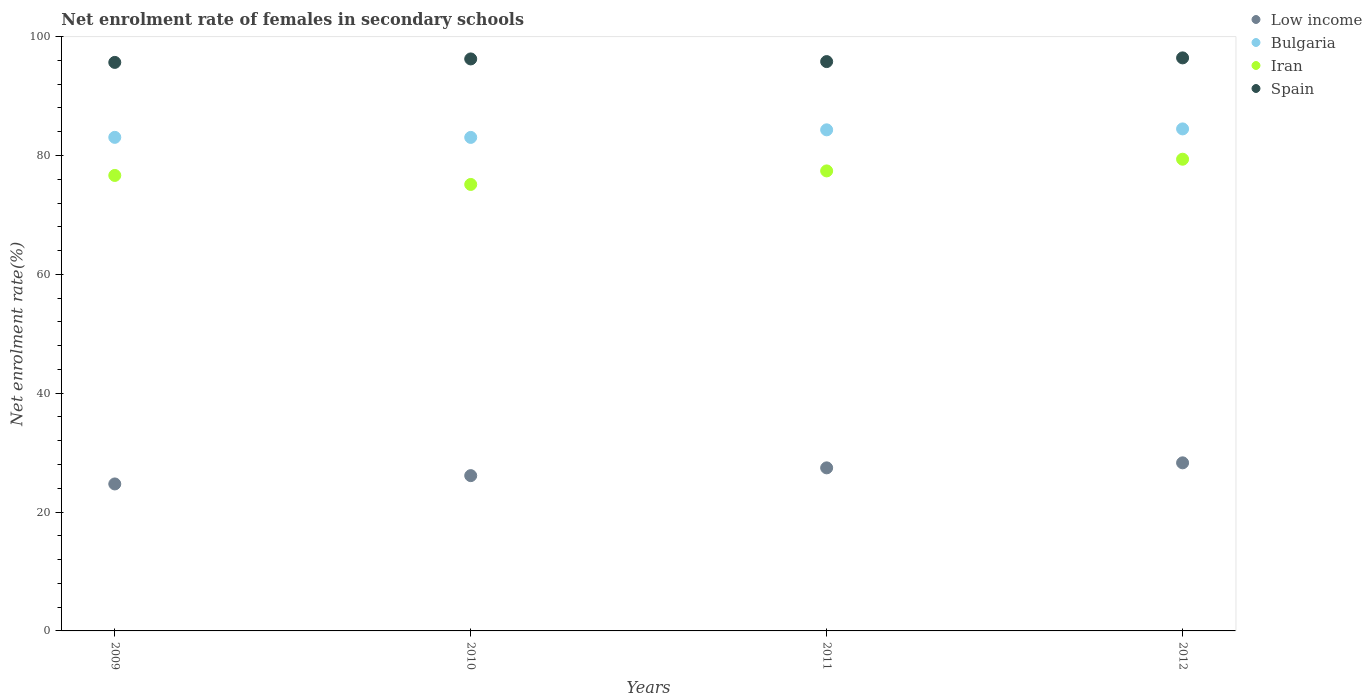Is the number of dotlines equal to the number of legend labels?
Offer a very short reply. Yes. What is the net enrolment rate of females in secondary schools in Spain in 2009?
Offer a terse response. 95.66. Across all years, what is the maximum net enrolment rate of females in secondary schools in Spain?
Offer a very short reply. 96.42. Across all years, what is the minimum net enrolment rate of females in secondary schools in Iran?
Offer a very short reply. 75.12. In which year was the net enrolment rate of females in secondary schools in Low income maximum?
Ensure brevity in your answer.  2012. What is the total net enrolment rate of females in secondary schools in Spain in the graph?
Provide a short and direct response. 384.12. What is the difference between the net enrolment rate of females in secondary schools in Spain in 2009 and that in 2012?
Your answer should be very brief. -0.76. What is the difference between the net enrolment rate of females in secondary schools in Bulgaria in 2011 and the net enrolment rate of females in secondary schools in Spain in 2009?
Offer a very short reply. -11.35. What is the average net enrolment rate of females in secondary schools in Iran per year?
Ensure brevity in your answer.  77.13. In the year 2011, what is the difference between the net enrolment rate of females in secondary schools in Iran and net enrolment rate of females in secondary schools in Spain?
Provide a succinct answer. -18.39. In how many years, is the net enrolment rate of females in secondary schools in Spain greater than 84 %?
Provide a short and direct response. 4. What is the ratio of the net enrolment rate of females in secondary schools in Iran in 2011 to that in 2012?
Offer a terse response. 0.98. Is the difference between the net enrolment rate of females in secondary schools in Iran in 2009 and 2011 greater than the difference between the net enrolment rate of females in secondary schools in Spain in 2009 and 2011?
Offer a very short reply. No. What is the difference between the highest and the second highest net enrolment rate of females in secondary schools in Iran?
Offer a terse response. 1.97. What is the difference between the highest and the lowest net enrolment rate of females in secondary schools in Bulgaria?
Your response must be concise. 1.43. In how many years, is the net enrolment rate of females in secondary schools in Bulgaria greater than the average net enrolment rate of females in secondary schools in Bulgaria taken over all years?
Offer a very short reply. 2. Does the net enrolment rate of females in secondary schools in Low income monotonically increase over the years?
Provide a succinct answer. Yes. How many dotlines are there?
Keep it short and to the point. 4. What is the difference between two consecutive major ticks on the Y-axis?
Make the answer very short. 20. Does the graph contain any zero values?
Offer a very short reply. No. Does the graph contain grids?
Make the answer very short. No. What is the title of the graph?
Provide a short and direct response. Net enrolment rate of females in secondary schools. What is the label or title of the X-axis?
Give a very brief answer. Years. What is the label or title of the Y-axis?
Give a very brief answer. Net enrolment rate(%). What is the Net enrolment rate(%) in Low income in 2009?
Your answer should be compact. 24.73. What is the Net enrolment rate(%) of Bulgaria in 2009?
Your answer should be compact. 83.05. What is the Net enrolment rate(%) in Iran in 2009?
Give a very brief answer. 76.64. What is the Net enrolment rate(%) of Spain in 2009?
Provide a short and direct response. 95.66. What is the Net enrolment rate(%) of Low income in 2010?
Make the answer very short. 26.13. What is the Net enrolment rate(%) in Bulgaria in 2010?
Offer a terse response. 83.04. What is the Net enrolment rate(%) of Iran in 2010?
Keep it short and to the point. 75.12. What is the Net enrolment rate(%) of Spain in 2010?
Keep it short and to the point. 96.24. What is the Net enrolment rate(%) of Low income in 2011?
Offer a terse response. 27.44. What is the Net enrolment rate(%) in Bulgaria in 2011?
Offer a very short reply. 84.31. What is the Net enrolment rate(%) in Iran in 2011?
Your answer should be very brief. 77.4. What is the Net enrolment rate(%) of Spain in 2011?
Your response must be concise. 95.8. What is the Net enrolment rate(%) of Low income in 2012?
Offer a terse response. 28.28. What is the Net enrolment rate(%) of Bulgaria in 2012?
Offer a very short reply. 84.47. What is the Net enrolment rate(%) in Iran in 2012?
Your response must be concise. 79.37. What is the Net enrolment rate(%) in Spain in 2012?
Give a very brief answer. 96.42. Across all years, what is the maximum Net enrolment rate(%) in Low income?
Offer a very short reply. 28.28. Across all years, what is the maximum Net enrolment rate(%) of Bulgaria?
Make the answer very short. 84.47. Across all years, what is the maximum Net enrolment rate(%) of Iran?
Offer a terse response. 79.37. Across all years, what is the maximum Net enrolment rate(%) in Spain?
Provide a short and direct response. 96.42. Across all years, what is the minimum Net enrolment rate(%) in Low income?
Your answer should be compact. 24.73. Across all years, what is the minimum Net enrolment rate(%) in Bulgaria?
Your response must be concise. 83.04. Across all years, what is the minimum Net enrolment rate(%) of Iran?
Give a very brief answer. 75.12. Across all years, what is the minimum Net enrolment rate(%) in Spain?
Provide a succinct answer. 95.66. What is the total Net enrolment rate(%) of Low income in the graph?
Offer a terse response. 106.58. What is the total Net enrolment rate(%) in Bulgaria in the graph?
Your answer should be very brief. 334.87. What is the total Net enrolment rate(%) of Iran in the graph?
Keep it short and to the point. 308.53. What is the total Net enrolment rate(%) of Spain in the graph?
Offer a very short reply. 384.12. What is the difference between the Net enrolment rate(%) in Low income in 2009 and that in 2010?
Offer a terse response. -1.4. What is the difference between the Net enrolment rate(%) in Bulgaria in 2009 and that in 2010?
Ensure brevity in your answer.  0.01. What is the difference between the Net enrolment rate(%) of Iran in 2009 and that in 2010?
Your answer should be compact. 1.51. What is the difference between the Net enrolment rate(%) of Spain in 2009 and that in 2010?
Offer a terse response. -0.59. What is the difference between the Net enrolment rate(%) in Low income in 2009 and that in 2011?
Provide a succinct answer. -2.71. What is the difference between the Net enrolment rate(%) of Bulgaria in 2009 and that in 2011?
Make the answer very short. -1.26. What is the difference between the Net enrolment rate(%) of Iran in 2009 and that in 2011?
Offer a terse response. -0.76. What is the difference between the Net enrolment rate(%) in Spain in 2009 and that in 2011?
Make the answer very short. -0.14. What is the difference between the Net enrolment rate(%) in Low income in 2009 and that in 2012?
Make the answer very short. -3.55. What is the difference between the Net enrolment rate(%) in Bulgaria in 2009 and that in 2012?
Make the answer very short. -1.42. What is the difference between the Net enrolment rate(%) in Iran in 2009 and that in 2012?
Provide a succinct answer. -2.73. What is the difference between the Net enrolment rate(%) of Spain in 2009 and that in 2012?
Your answer should be compact. -0.76. What is the difference between the Net enrolment rate(%) in Low income in 2010 and that in 2011?
Provide a succinct answer. -1.31. What is the difference between the Net enrolment rate(%) of Bulgaria in 2010 and that in 2011?
Ensure brevity in your answer.  -1.27. What is the difference between the Net enrolment rate(%) in Iran in 2010 and that in 2011?
Offer a very short reply. -2.28. What is the difference between the Net enrolment rate(%) in Spain in 2010 and that in 2011?
Offer a terse response. 0.45. What is the difference between the Net enrolment rate(%) of Low income in 2010 and that in 2012?
Your answer should be compact. -2.15. What is the difference between the Net enrolment rate(%) in Bulgaria in 2010 and that in 2012?
Give a very brief answer. -1.43. What is the difference between the Net enrolment rate(%) in Iran in 2010 and that in 2012?
Ensure brevity in your answer.  -4.24. What is the difference between the Net enrolment rate(%) in Spain in 2010 and that in 2012?
Make the answer very short. -0.18. What is the difference between the Net enrolment rate(%) in Low income in 2011 and that in 2012?
Offer a terse response. -0.85. What is the difference between the Net enrolment rate(%) in Bulgaria in 2011 and that in 2012?
Make the answer very short. -0.16. What is the difference between the Net enrolment rate(%) of Iran in 2011 and that in 2012?
Ensure brevity in your answer.  -1.97. What is the difference between the Net enrolment rate(%) in Spain in 2011 and that in 2012?
Provide a succinct answer. -0.62. What is the difference between the Net enrolment rate(%) in Low income in 2009 and the Net enrolment rate(%) in Bulgaria in 2010?
Offer a terse response. -58.31. What is the difference between the Net enrolment rate(%) in Low income in 2009 and the Net enrolment rate(%) in Iran in 2010?
Offer a terse response. -50.39. What is the difference between the Net enrolment rate(%) in Low income in 2009 and the Net enrolment rate(%) in Spain in 2010?
Your answer should be compact. -71.51. What is the difference between the Net enrolment rate(%) in Bulgaria in 2009 and the Net enrolment rate(%) in Iran in 2010?
Your response must be concise. 7.92. What is the difference between the Net enrolment rate(%) of Bulgaria in 2009 and the Net enrolment rate(%) of Spain in 2010?
Provide a short and direct response. -13.2. What is the difference between the Net enrolment rate(%) in Iran in 2009 and the Net enrolment rate(%) in Spain in 2010?
Your answer should be very brief. -19.6. What is the difference between the Net enrolment rate(%) in Low income in 2009 and the Net enrolment rate(%) in Bulgaria in 2011?
Offer a terse response. -59.58. What is the difference between the Net enrolment rate(%) of Low income in 2009 and the Net enrolment rate(%) of Iran in 2011?
Provide a succinct answer. -52.67. What is the difference between the Net enrolment rate(%) in Low income in 2009 and the Net enrolment rate(%) in Spain in 2011?
Offer a terse response. -71.06. What is the difference between the Net enrolment rate(%) of Bulgaria in 2009 and the Net enrolment rate(%) of Iran in 2011?
Provide a short and direct response. 5.65. What is the difference between the Net enrolment rate(%) of Bulgaria in 2009 and the Net enrolment rate(%) of Spain in 2011?
Your answer should be compact. -12.75. What is the difference between the Net enrolment rate(%) in Iran in 2009 and the Net enrolment rate(%) in Spain in 2011?
Ensure brevity in your answer.  -19.16. What is the difference between the Net enrolment rate(%) in Low income in 2009 and the Net enrolment rate(%) in Bulgaria in 2012?
Provide a succinct answer. -59.74. What is the difference between the Net enrolment rate(%) of Low income in 2009 and the Net enrolment rate(%) of Iran in 2012?
Provide a succinct answer. -54.64. What is the difference between the Net enrolment rate(%) in Low income in 2009 and the Net enrolment rate(%) in Spain in 2012?
Give a very brief answer. -71.69. What is the difference between the Net enrolment rate(%) of Bulgaria in 2009 and the Net enrolment rate(%) of Iran in 2012?
Give a very brief answer. 3.68. What is the difference between the Net enrolment rate(%) in Bulgaria in 2009 and the Net enrolment rate(%) in Spain in 2012?
Give a very brief answer. -13.37. What is the difference between the Net enrolment rate(%) of Iran in 2009 and the Net enrolment rate(%) of Spain in 2012?
Your response must be concise. -19.78. What is the difference between the Net enrolment rate(%) in Low income in 2010 and the Net enrolment rate(%) in Bulgaria in 2011?
Your answer should be very brief. -58.18. What is the difference between the Net enrolment rate(%) of Low income in 2010 and the Net enrolment rate(%) of Iran in 2011?
Offer a very short reply. -51.27. What is the difference between the Net enrolment rate(%) of Low income in 2010 and the Net enrolment rate(%) of Spain in 2011?
Offer a terse response. -69.67. What is the difference between the Net enrolment rate(%) in Bulgaria in 2010 and the Net enrolment rate(%) in Iran in 2011?
Provide a succinct answer. 5.64. What is the difference between the Net enrolment rate(%) in Bulgaria in 2010 and the Net enrolment rate(%) in Spain in 2011?
Provide a short and direct response. -12.76. What is the difference between the Net enrolment rate(%) of Iran in 2010 and the Net enrolment rate(%) of Spain in 2011?
Provide a short and direct response. -20.67. What is the difference between the Net enrolment rate(%) in Low income in 2010 and the Net enrolment rate(%) in Bulgaria in 2012?
Provide a succinct answer. -58.34. What is the difference between the Net enrolment rate(%) in Low income in 2010 and the Net enrolment rate(%) in Iran in 2012?
Offer a very short reply. -53.24. What is the difference between the Net enrolment rate(%) in Low income in 2010 and the Net enrolment rate(%) in Spain in 2012?
Offer a terse response. -70.29. What is the difference between the Net enrolment rate(%) of Bulgaria in 2010 and the Net enrolment rate(%) of Iran in 2012?
Your response must be concise. 3.67. What is the difference between the Net enrolment rate(%) in Bulgaria in 2010 and the Net enrolment rate(%) in Spain in 2012?
Make the answer very short. -13.38. What is the difference between the Net enrolment rate(%) of Iran in 2010 and the Net enrolment rate(%) of Spain in 2012?
Keep it short and to the point. -21.3. What is the difference between the Net enrolment rate(%) of Low income in 2011 and the Net enrolment rate(%) of Bulgaria in 2012?
Your answer should be very brief. -57.03. What is the difference between the Net enrolment rate(%) of Low income in 2011 and the Net enrolment rate(%) of Iran in 2012?
Keep it short and to the point. -51.93. What is the difference between the Net enrolment rate(%) of Low income in 2011 and the Net enrolment rate(%) of Spain in 2012?
Offer a terse response. -68.98. What is the difference between the Net enrolment rate(%) in Bulgaria in 2011 and the Net enrolment rate(%) in Iran in 2012?
Offer a terse response. 4.94. What is the difference between the Net enrolment rate(%) in Bulgaria in 2011 and the Net enrolment rate(%) in Spain in 2012?
Ensure brevity in your answer.  -12.11. What is the difference between the Net enrolment rate(%) of Iran in 2011 and the Net enrolment rate(%) of Spain in 2012?
Provide a succinct answer. -19.02. What is the average Net enrolment rate(%) in Low income per year?
Your response must be concise. 26.64. What is the average Net enrolment rate(%) of Bulgaria per year?
Your answer should be very brief. 83.72. What is the average Net enrolment rate(%) in Iran per year?
Make the answer very short. 77.13. What is the average Net enrolment rate(%) of Spain per year?
Provide a succinct answer. 96.03. In the year 2009, what is the difference between the Net enrolment rate(%) of Low income and Net enrolment rate(%) of Bulgaria?
Provide a short and direct response. -58.32. In the year 2009, what is the difference between the Net enrolment rate(%) in Low income and Net enrolment rate(%) in Iran?
Give a very brief answer. -51.91. In the year 2009, what is the difference between the Net enrolment rate(%) of Low income and Net enrolment rate(%) of Spain?
Provide a short and direct response. -70.93. In the year 2009, what is the difference between the Net enrolment rate(%) in Bulgaria and Net enrolment rate(%) in Iran?
Offer a terse response. 6.41. In the year 2009, what is the difference between the Net enrolment rate(%) of Bulgaria and Net enrolment rate(%) of Spain?
Make the answer very short. -12.61. In the year 2009, what is the difference between the Net enrolment rate(%) of Iran and Net enrolment rate(%) of Spain?
Provide a short and direct response. -19.02. In the year 2010, what is the difference between the Net enrolment rate(%) in Low income and Net enrolment rate(%) in Bulgaria?
Keep it short and to the point. -56.91. In the year 2010, what is the difference between the Net enrolment rate(%) of Low income and Net enrolment rate(%) of Iran?
Provide a short and direct response. -49. In the year 2010, what is the difference between the Net enrolment rate(%) of Low income and Net enrolment rate(%) of Spain?
Offer a very short reply. -70.11. In the year 2010, what is the difference between the Net enrolment rate(%) of Bulgaria and Net enrolment rate(%) of Iran?
Offer a very short reply. 7.91. In the year 2010, what is the difference between the Net enrolment rate(%) of Bulgaria and Net enrolment rate(%) of Spain?
Offer a terse response. -13.2. In the year 2010, what is the difference between the Net enrolment rate(%) of Iran and Net enrolment rate(%) of Spain?
Ensure brevity in your answer.  -21.12. In the year 2011, what is the difference between the Net enrolment rate(%) of Low income and Net enrolment rate(%) of Bulgaria?
Your answer should be compact. -56.88. In the year 2011, what is the difference between the Net enrolment rate(%) in Low income and Net enrolment rate(%) in Iran?
Your answer should be compact. -49.96. In the year 2011, what is the difference between the Net enrolment rate(%) of Low income and Net enrolment rate(%) of Spain?
Your response must be concise. -68.36. In the year 2011, what is the difference between the Net enrolment rate(%) in Bulgaria and Net enrolment rate(%) in Iran?
Your answer should be very brief. 6.91. In the year 2011, what is the difference between the Net enrolment rate(%) of Bulgaria and Net enrolment rate(%) of Spain?
Provide a short and direct response. -11.48. In the year 2011, what is the difference between the Net enrolment rate(%) of Iran and Net enrolment rate(%) of Spain?
Offer a terse response. -18.39. In the year 2012, what is the difference between the Net enrolment rate(%) in Low income and Net enrolment rate(%) in Bulgaria?
Provide a short and direct response. -56.19. In the year 2012, what is the difference between the Net enrolment rate(%) of Low income and Net enrolment rate(%) of Iran?
Offer a terse response. -51.09. In the year 2012, what is the difference between the Net enrolment rate(%) of Low income and Net enrolment rate(%) of Spain?
Your answer should be compact. -68.14. In the year 2012, what is the difference between the Net enrolment rate(%) in Bulgaria and Net enrolment rate(%) in Iran?
Your answer should be compact. 5.1. In the year 2012, what is the difference between the Net enrolment rate(%) of Bulgaria and Net enrolment rate(%) of Spain?
Your answer should be very brief. -11.95. In the year 2012, what is the difference between the Net enrolment rate(%) in Iran and Net enrolment rate(%) in Spain?
Your answer should be compact. -17.05. What is the ratio of the Net enrolment rate(%) in Low income in 2009 to that in 2010?
Offer a very short reply. 0.95. What is the ratio of the Net enrolment rate(%) of Bulgaria in 2009 to that in 2010?
Keep it short and to the point. 1. What is the ratio of the Net enrolment rate(%) in Iran in 2009 to that in 2010?
Your answer should be very brief. 1.02. What is the ratio of the Net enrolment rate(%) in Low income in 2009 to that in 2011?
Provide a short and direct response. 0.9. What is the ratio of the Net enrolment rate(%) in Low income in 2009 to that in 2012?
Your response must be concise. 0.87. What is the ratio of the Net enrolment rate(%) of Bulgaria in 2009 to that in 2012?
Your answer should be compact. 0.98. What is the ratio of the Net enrolment rate(%) of Iran in 2009 to that in 2012?
Make the answer very short. 0.97. What is the ratio of the Net enrolment rate(%) of Low income in 2010 to that in 2011?
Your response must be concise. 0.95. What is the ratio of the Net enrolment rate(%) in Bulgaria in 2010 to that in 2011?
Your answer should be very brief. 0.98. What is the ratio of the Net enrolment rate(%) in Iran in 2010 to that in 2011?
Your answer should be very brief. 0.97. What is the ratio of the Net enrolment rate(%) of Low income in 2010 to that in 2012?
Ensure brevity in your answer.  0.92. What is the ratio of the Net enrolment rate(%) of Bulgaria in 2010 to that in 2012?
Offer a terse response. 0.98. What is the ratio of the Net enrolment rate(%) in Iran in 2010 to that in 2012?
Give a very brief answer. 0.95. What is the ratio of the Net enrolment rate(%) in Low income in 2011 to that in 2012?
Provide a succinct answer. 0.97. What is the ratio of the Net enrolment rate(%) of Bulgaria in 2011 to that in 2012?
Your answer should be very brief. 1. What is the ratio of the Net enrolment rate(%) of Iran in 2011 to that in 2012?
Provide a short and direct response. 0.98. What is the difference between the highest and the second highest Net enrolment rate(%) in Low income?
Keep it short and to the point. 0.85. What is the difference between the highest and the second highest Net enrolment rate(%) of Bulgaria?
Your answer should be very brief. 0.16. What is the difference between the highest and the second highest Net enrolment rate(%) in Iran?
Provide a short and direct response. 1.97. What is the difference between the highest and the second highest Net enrolment rate(%) in Spain?
Provide a short and direct response. 0.18. What is the difference between the highest and the lowest Net enrolment rate(%) in Low income?
Your answer should be compact. 3.55. What is the difference between the highest and the lowest Net enrolment rate(%) of Bulgaria?
Keep it short and to the point. 1.43. What is the difference between the highest and the lowest Net enrolment rate(%) in Iran?
Your response must be concise. 4.24. What is the difference between the highest and the lowest Net enrolment rate(%) of Spain?
Make the answer very short. 0.76. 